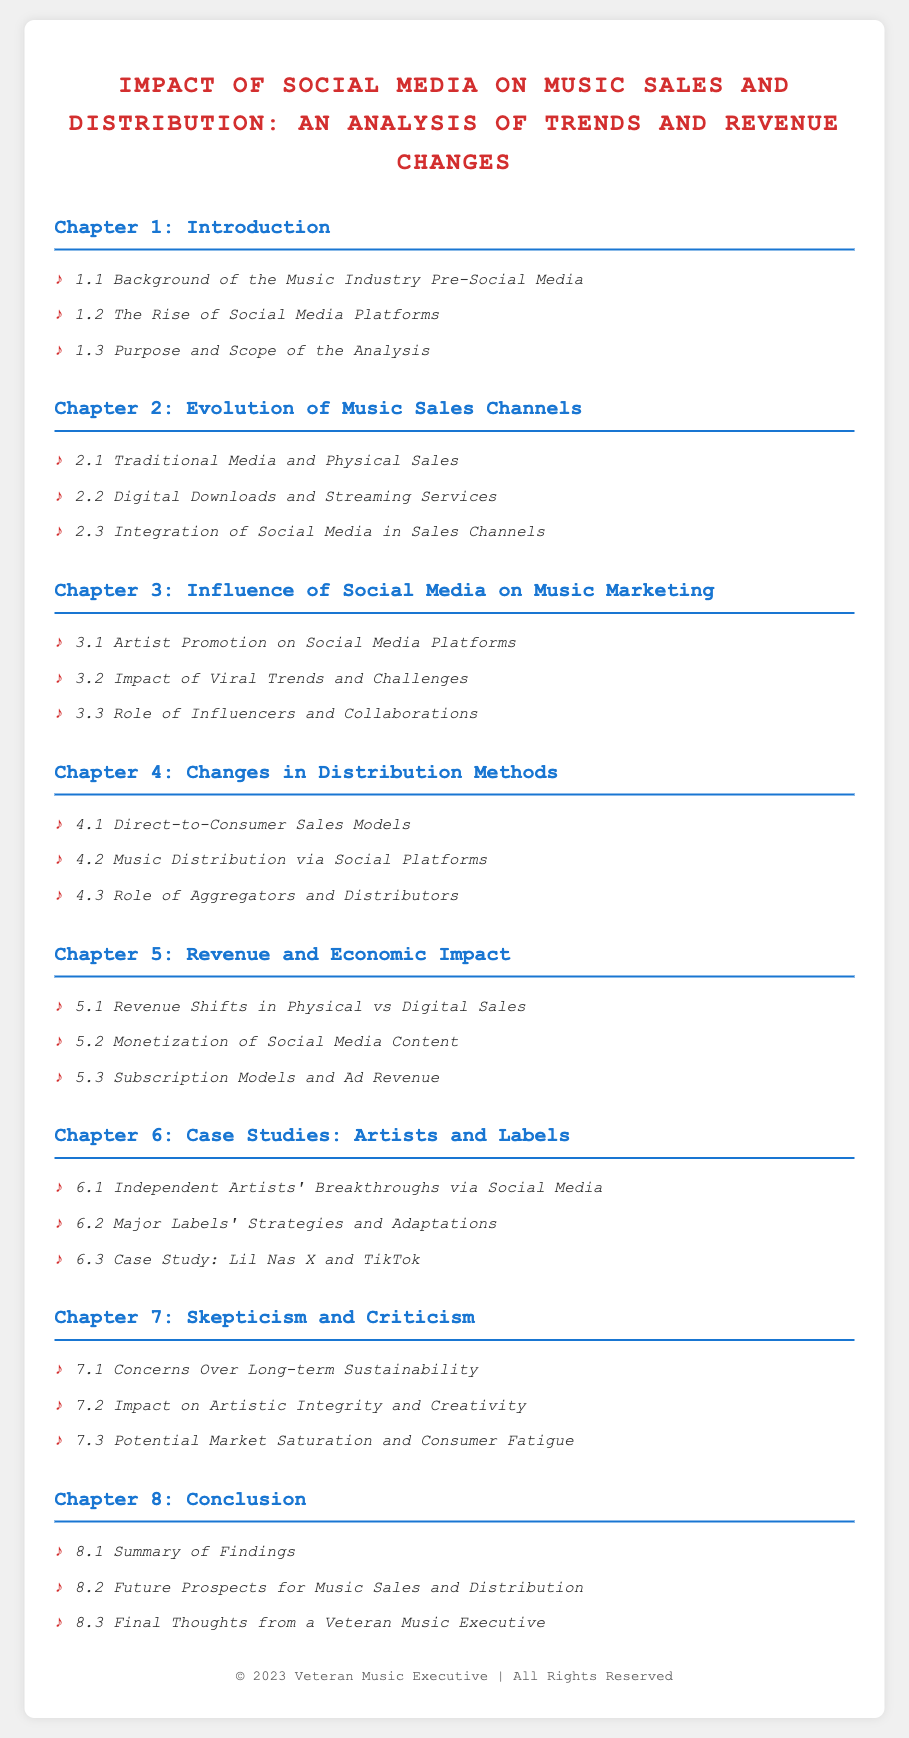what is the title of the document? The title of the document is indicated at the top and provides the main focus of the content.
Answer: Impact of Social Media on Music Sales and Distribution: An Analysis of Trends and Revenue Changes how many chapters does the document contain? The document is structured into chapters, and counting them provides the answer.
Answer: 8 which chapter discusses the revenue shifts in physical vs digital sales? This topic is specifically mentioned under the chapter that analyzes revenue and economic impact.
Answer: Chapter 5 who is the case study focused on in Chapter 6? The document mentions specific artists and one major case study that exemplifies social media's impact.
Answer: Lil Nas X what is one concern mentioned in Chapter 7 about the long-term effects of social media? This chapter highlights various criticisms and skepticism regarding social media's impact on the industry.
Answer: Concerns Over Long-term Sustainability 